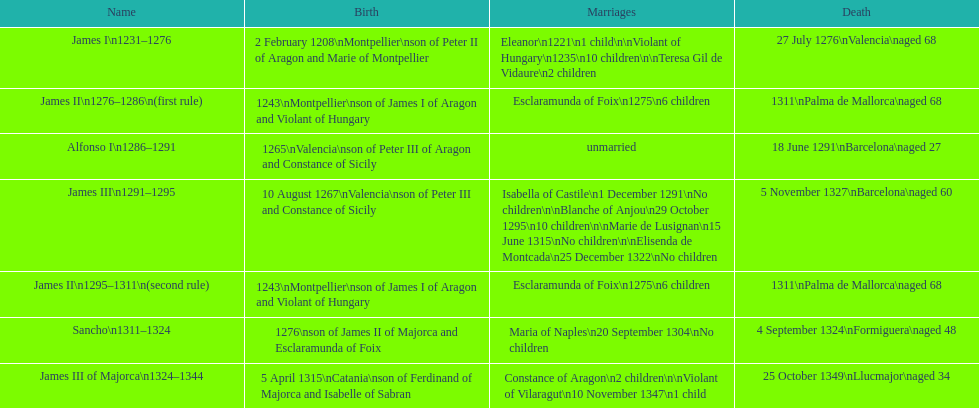Which two monarchs had no children? Alfonso I, Sancho. 